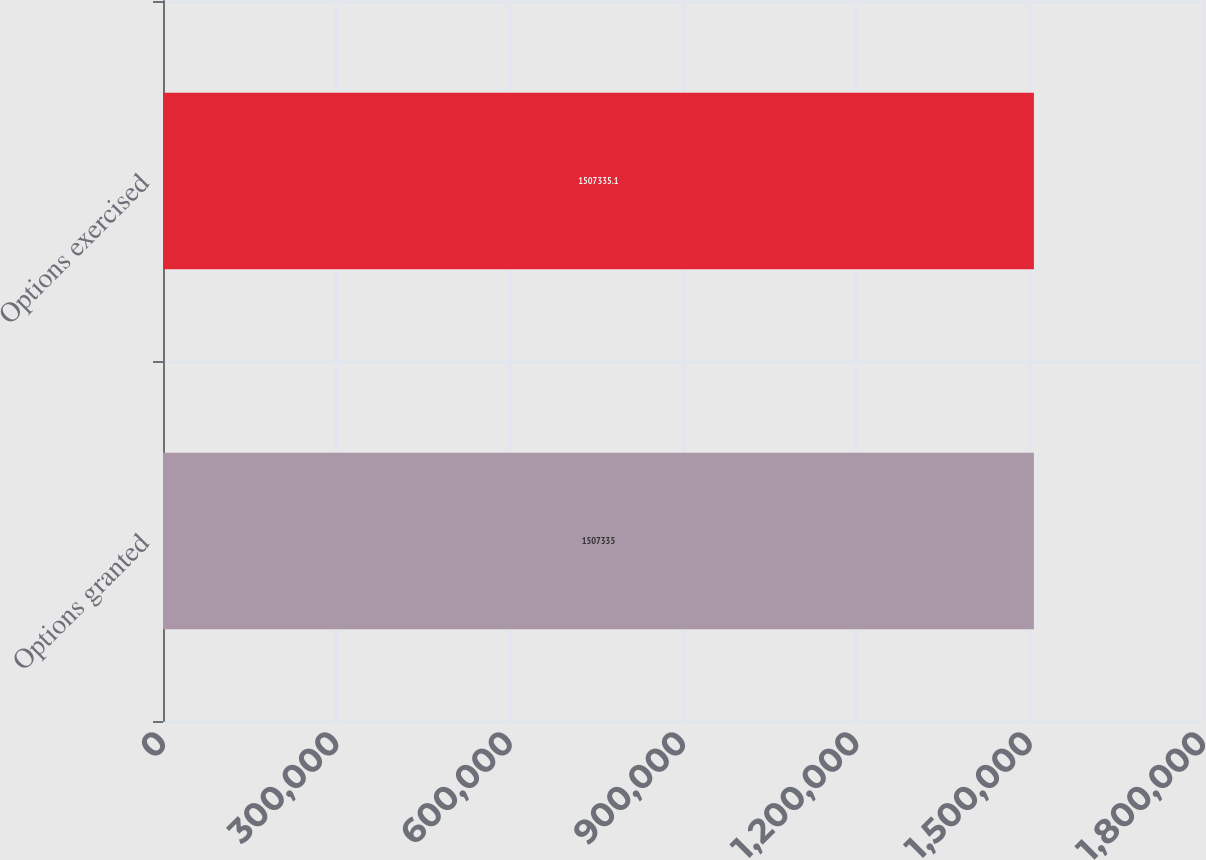Convert chart. <chart><loc_0><loc_0><loc_500><loc_500><bar_chart><fcel>Options granted<fcel>Options exercised<nl><fcel>1.50734e+06<fcel>1.50734e+06<nl></chart> 